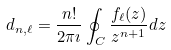<formula> <loc_0><loc_0><loc_500><loc_500>d _ { n , \ell } = \frac { n ! } { 2 \pi \imath } \oint _ { C } \frac { f _ { \ell } ( z ) } { z ^ { n + 1 } } d z</formula> 